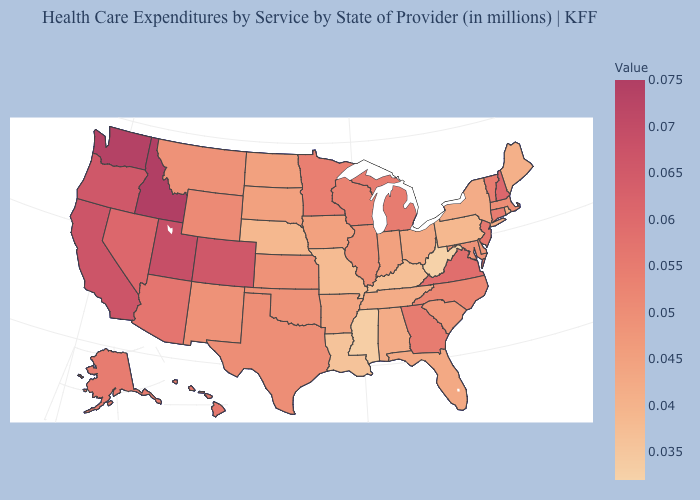Does the map have missing data?
Short answer required. No. Does Michigan have the highest value in the MidWest?
Write a very short answer. Yes. Which states have the lowest value in the MidWest?
Quick response, please. Missouri. Which states have the highest value in the USA?
Be succinct. Idaho. Does Ohio have the highest value in the USA?
Give a very brief answer. No. Does Massachusetts have the lowest value in the Northeast?
Answer briefly. No. Which states have the lowest value in the MidWest?
Short answer required. Missouri. 